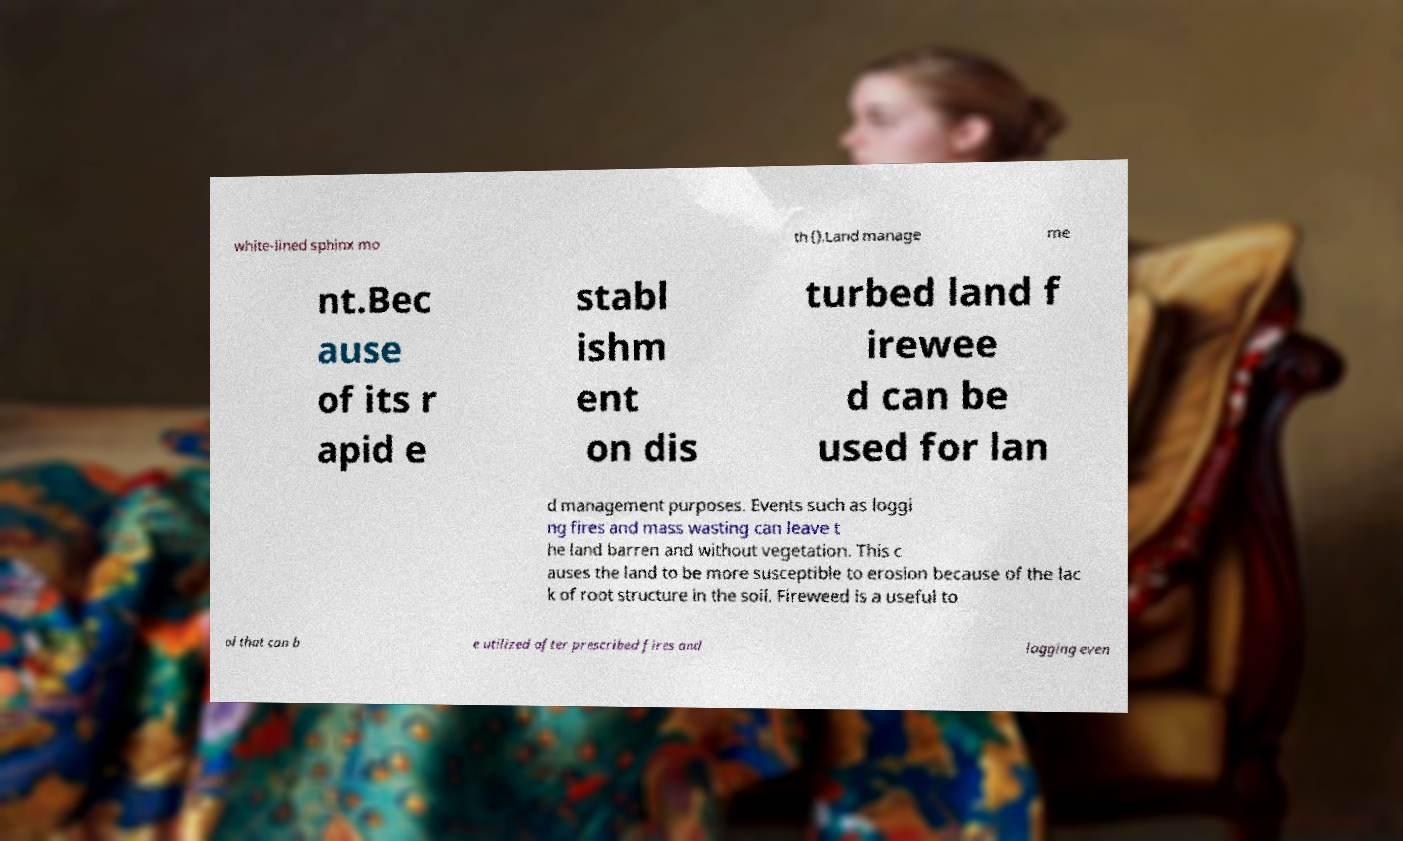Could you assist in decoding the text presented in this image and type it out clearly? white-lined sphinx mo th ().Land manage me nt.Bec ause of its r apid e stabl ishm ent on dis turbed land f irewee d can be used for lan d management purposes. Events such as loggi ng fires and mass wasting can leave t he land barren and without vegetation. This c auses the land to be more susceptible to erosion because of the lac k of root structure in the soil. Fireweed is a useful to ol that can b e utilized after prescribed fires and logging even 